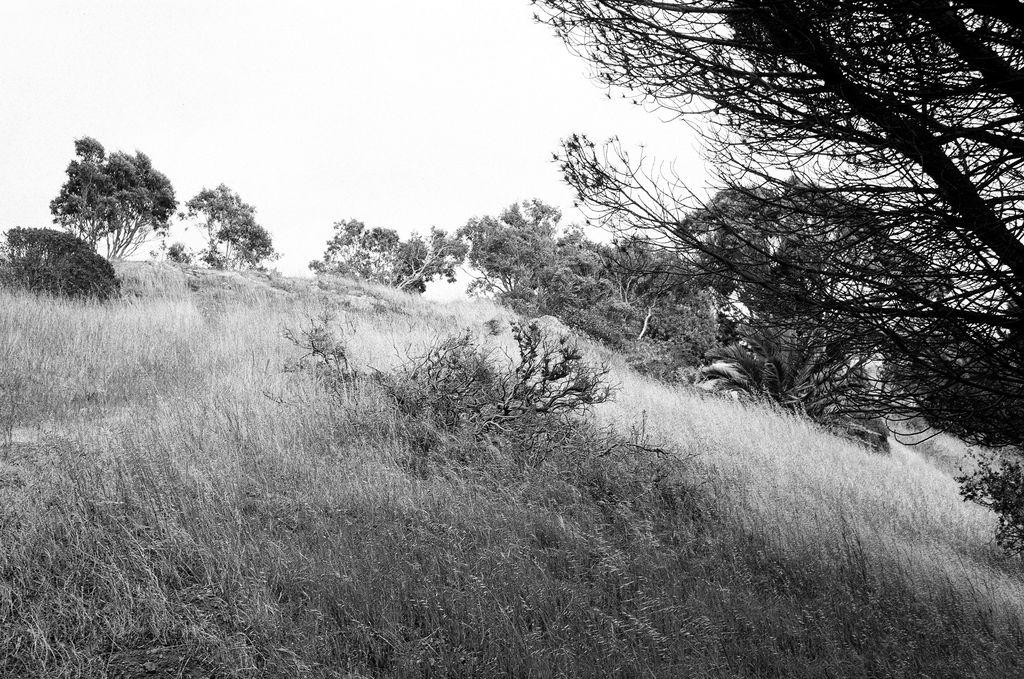What type of vegetation can be seen in the image? There are bushes and trees in the image. What is the color scheme of the image? The image is black and white in color. What advertisement can be seen on the trees in the image? There are no advertisements present in the image; it only features bushes and trees. What time of day is it in the image? The time of day cannot be determined from the image, as there are no clues or indicators of the time. 